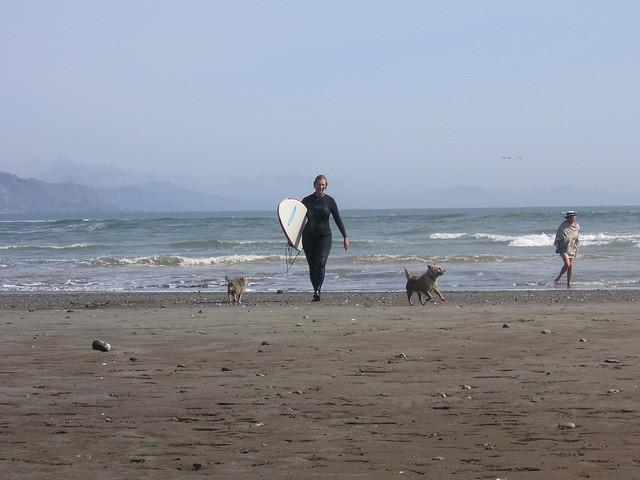How many people are in the photo?
Keep it brief. 2. What is the gender of the human?
Concise answer only. Female. Is this person walking to or from the water?
Give a very brief answer. From. Is it a high tide?
Keep it brief. No. Is the person walking away from the water?
Give a very brief answer. Yes. Can you see any animals?
Quick response, please. Yes. Do the dogs belong to the surfer?
Write a very short answer. Yes. How many dogs are on the beach?
Give a very brief answer. 2. Is it a hot summer day?
Give a very brief answer. Yes. What color is the surfboard?
Quick response, please. White. Is the sun rising?
Keep it brief. No. 